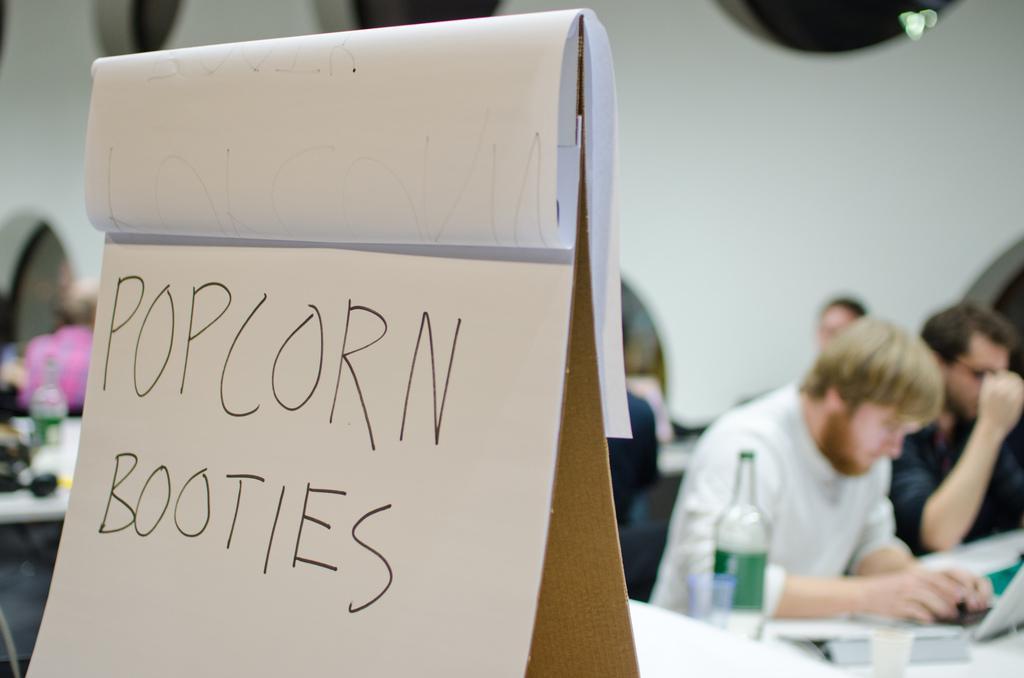Could you give a brief overview of what you see in this image? In this image, we can see a notepad contains some written text. There are persons on the right side of the image wearing clothes. There is a bottle on the table which is in the bottom right of the image. In the background, image is blurred. 